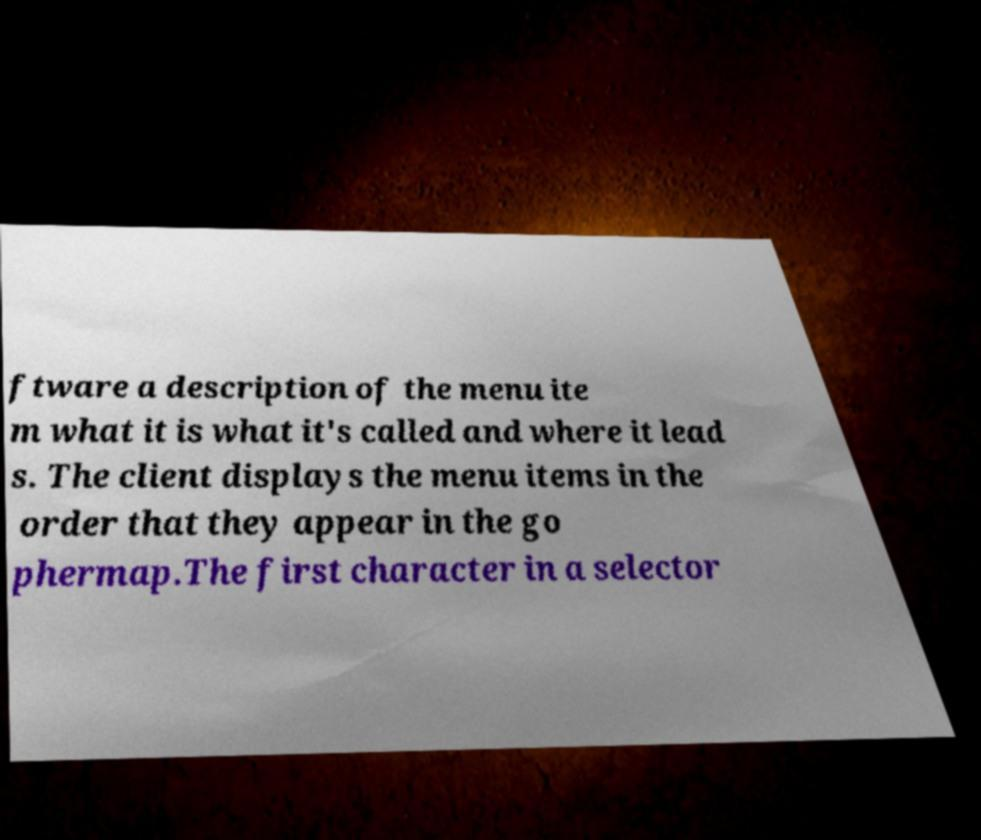There's text embedded in this image that I need extracted. Can you transcribe it verbatim? ftware a description of the menu ite m what it is what it's called and where it lead s. The client displays the menu items in the order that they appear in the go phermap.The first character in a selector 